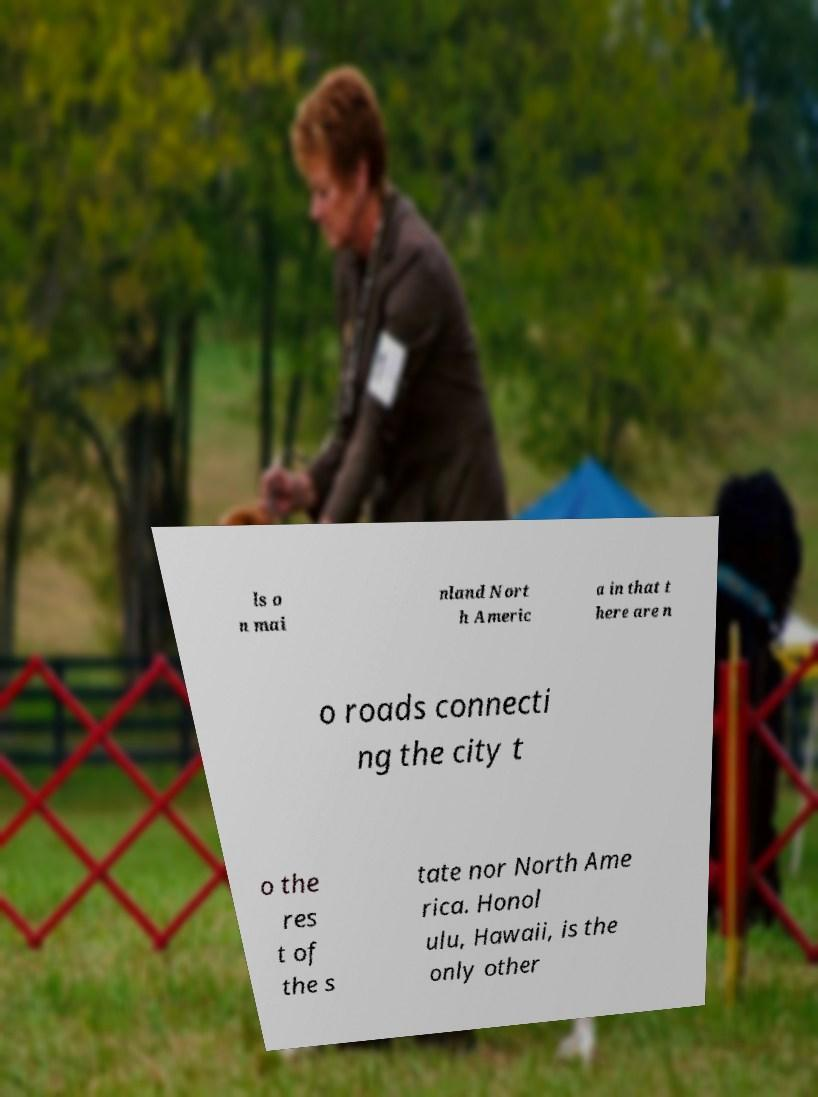Could you extract and type out the text from this image? ls o n mai nland Nort h Americ a in that t here are n o roads connecti ng the city t o the res t of the s tate nor North Ame rica. Honol ulu, Hawaii, is the only other 